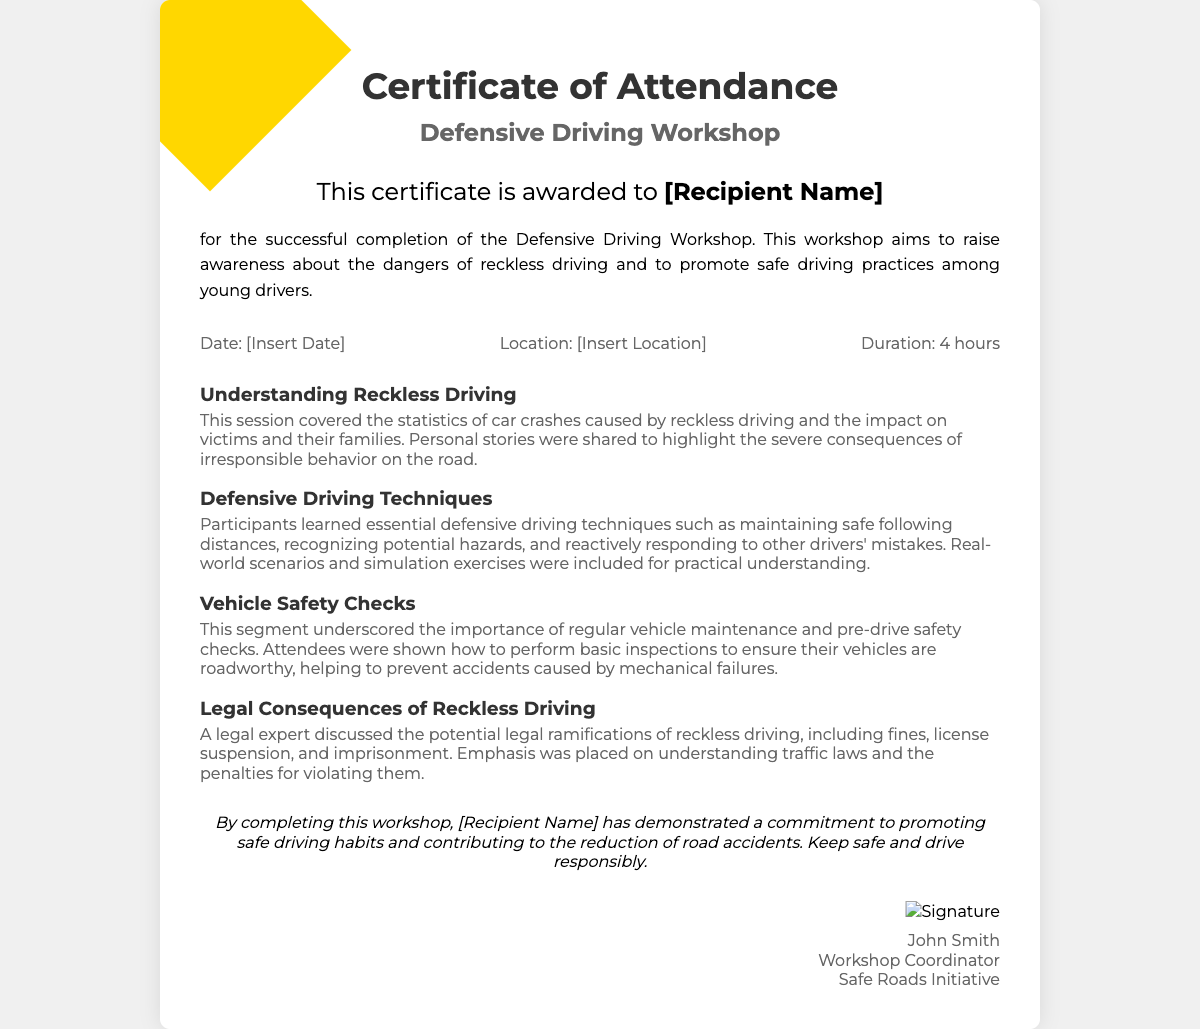What is the title of the workshop? The title of the workshop is prominently displayed under the main heading of the certificate.
Answer: Defensive Driving Workshop Who is the certificate awarded to? The recipient's name is emphasized in the section specifically designated for that purpose on the document.
Answer: [Recipient Name] What is the total duration of the workshop? The duration is stated in a specific section about the workshop details.
Answer: 4 hours What important driving technique is mentioned in the document? The document lists key topics covered in the workshop, including a specific focus on one technique.
Answer: Defensive Driving Techniques What date is likely shown on this certificate? A placeholder for the date indicates that it's an essential detail of the certification.
Answer: [Insert Date] What is the overall purpose of the Defensive Driving Workshop? The message section outlines the main objective of the workshop directly after the recipient's acknowledgment.
Answer: Raise awareness about the dangers of reckless driving Who coordinated the workshop? The signature section contains the name of the person responsible for coordinating the event.
Answer: John Smith What is one of the legal consequences of reckless driving mentioned? The document states potential legal ramifications discussed in one of the workshop topics.
Answer: Fines What does the closing message encourage participants to do? The closing message emphasizes a specific action related to road safety after completing the workshop.
Answer: Drive responsibly 